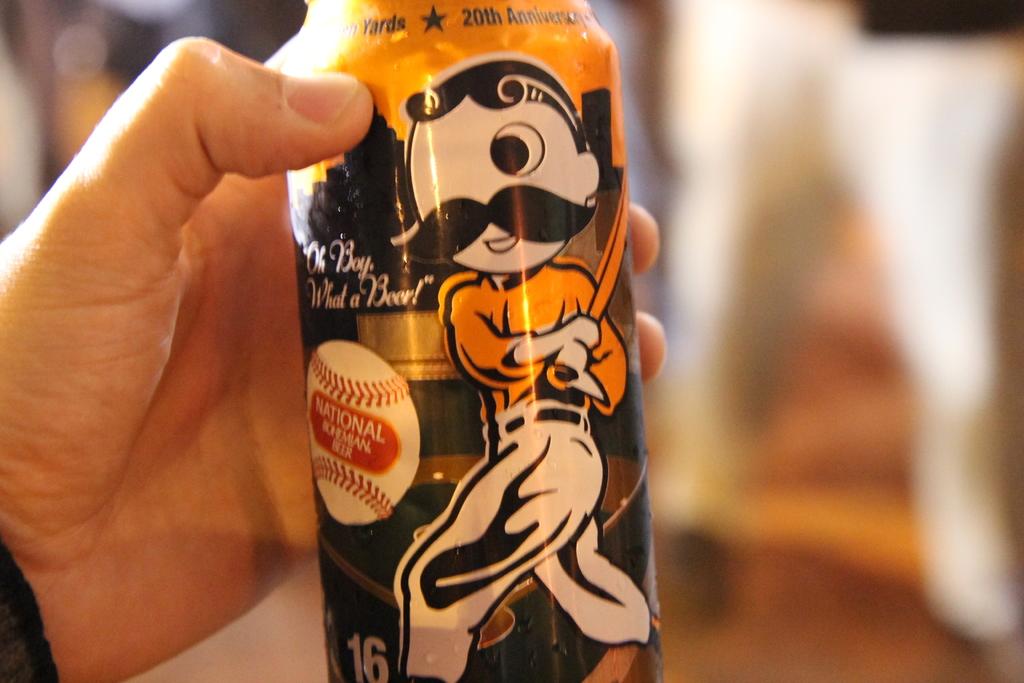What number anniversary is the can design celebrating?
Give a very brief answer. 20th. What is in quotes?
Offer a very short reply. Oh boy what a beer. 